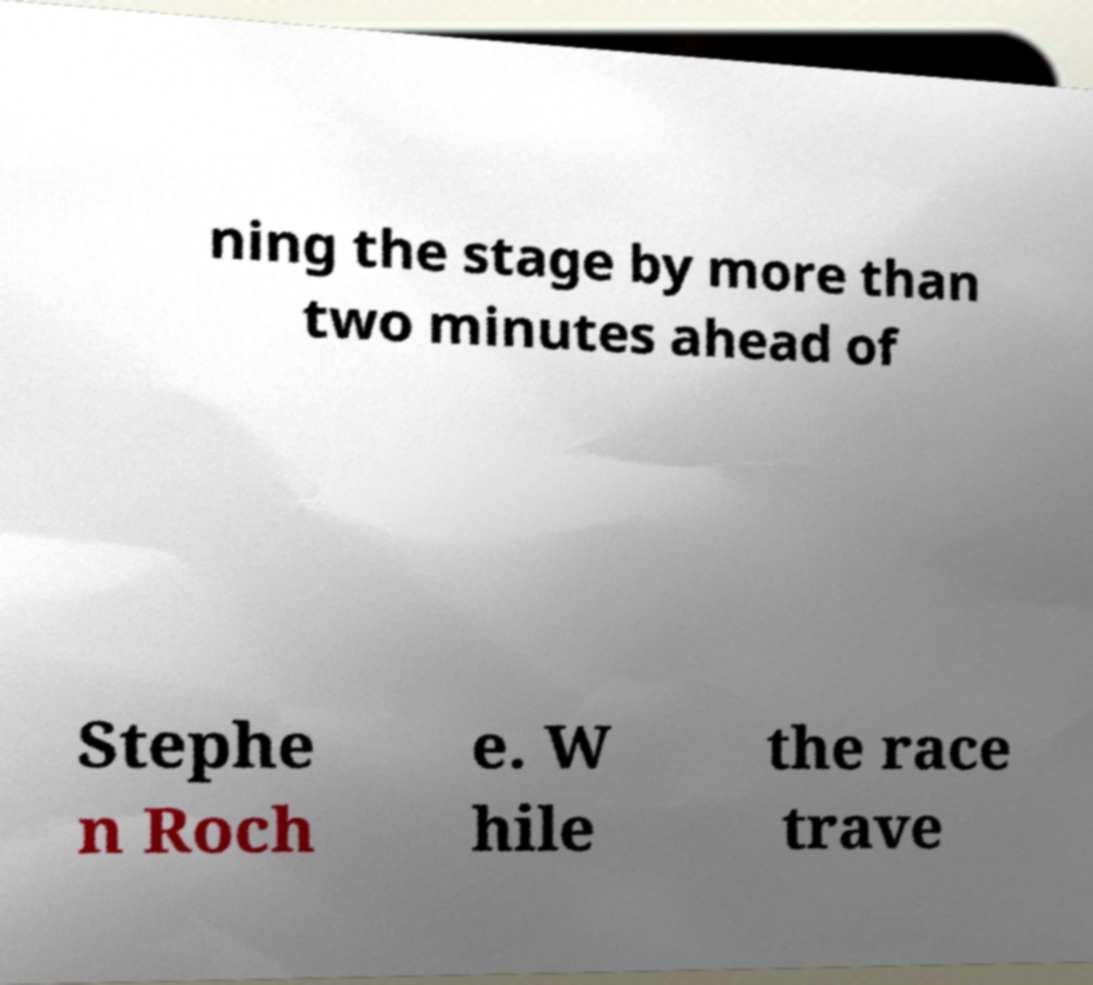I need the written content from this picture converted into text. Can you do that? ning the stage by more than two minutes ahead of Stephe n Roch e. W hile the race trave 